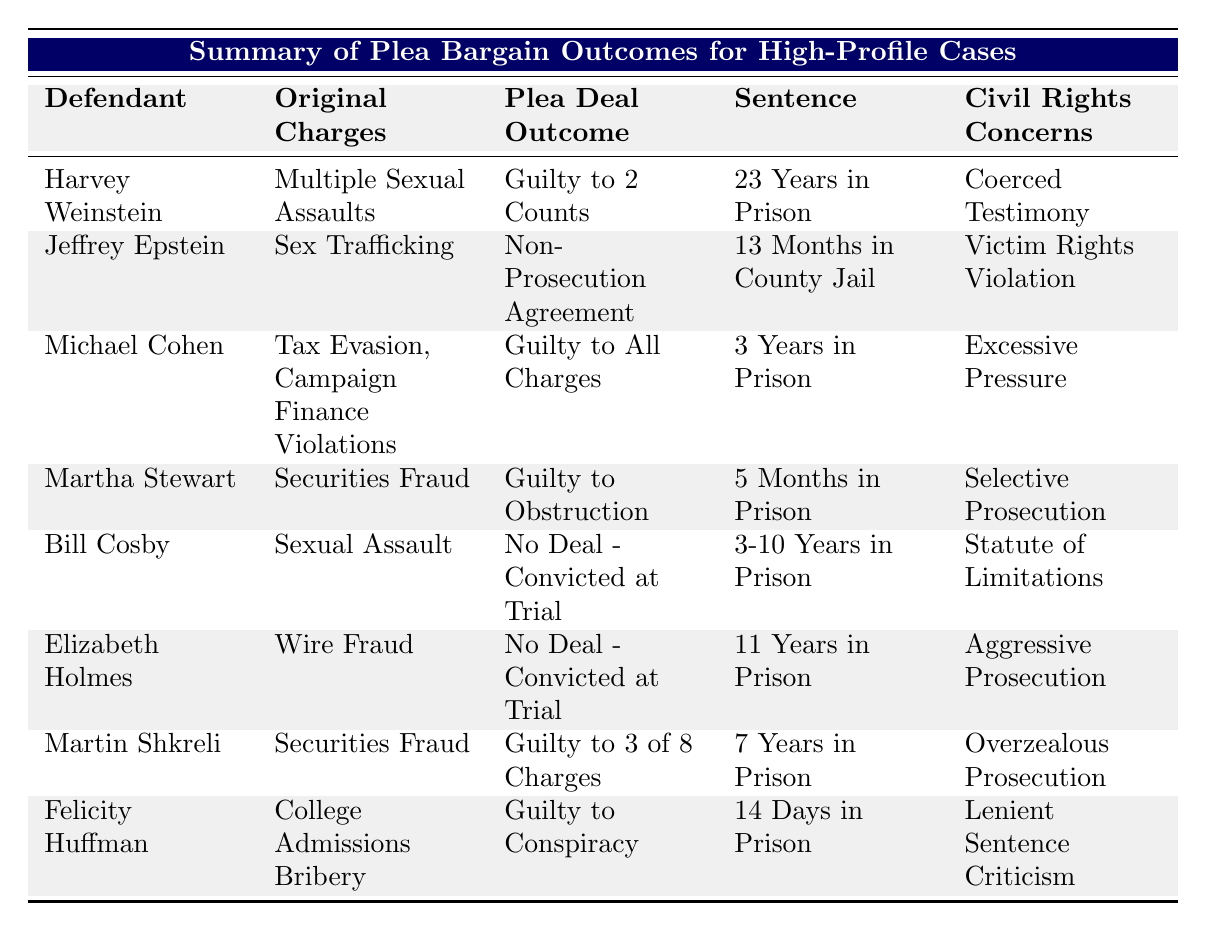What is the sentence given to Harvey Weinstein? The table lists the sentence for Harvey Weinstein in the "Sentence" column, which indicates he received "23 Years in Prison."
Answer: 23 Years in Prison Which defendant received the shortest sentence? By scanning through the "Sentence" column, Felicity Huffman received the shortest sentence of "14 Days in Prison."
Answer: 14 Days in Prison How many years did Michael Cohen receive for his charges? The sentence for Michael Cohen, as indicated in the "Sentence" column, is "3 Years in Prison."
Answer: 3 Years in Prison Is it true that Martha Stewart struck a plea deal for her charges? By looking at the "Plea Deal Outcome," we see Martha Stewart was found "Guilty to Obstruction," indicating she accepted a deal rather than going to trial. Therefore, the statement is true.
Answer: Yes What was the total prison time for all defendants who accepted plea deals? Summing the sentences for defendants who accepted plea deals: Harvey Weinstein (23 years) + Michael Cohen (3 years) + Martha Stewart (5 months, which is approximately 0.42 years) + Martin Shkreli (7 years) + Felicity Huffman (14 days, approximately 0.04 years) gives us a total of 23 + 3 + 0.42 + 7 + 0.04 = 33.46 years.
Answer: 33.46 years Did any defendant receive a non-prosecution agreement? Yes, Jeffrey Epstein is noted under the "Plea Deal Outcome" as receiving a "Non-Prosecution Agreement," indicating he did not face prosecution in exchange for his cooperation.
Answer: Yes Which defendant had civil rights concerns categorized as "Selective Prosecution"? Checking the "Civil Rights Concerns" column, this is linked to Martha Stewart, who had concerns labeled as "Selective Prosecution."
Answer: Martha Stewart Among the defendants, who had the most severe civil rights concern? Reviewing the "Civil Rights Concerns" column, the term "Victim Rights Violation" associated with Jeffrey Epstein may suggest a more serious legal implication compared to others, as it directly concerns the rights of victims.
Answer: Jeffrey Epstein 